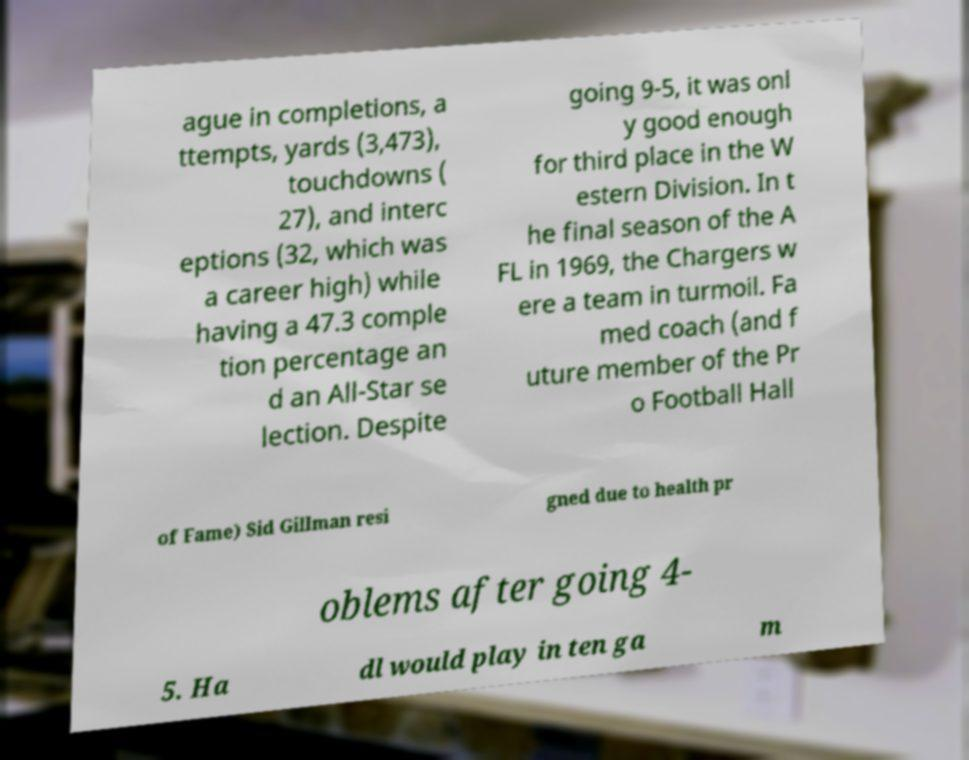I need the written content from this picture converted into text. Can you do that? ague in completions, a ttempts, yards (3,473), touchdowns ( 27), and interc eptions (32, which was a career high) while having a 47.3 comple tion percentage an d an All-Star se lection. Despite going 9-5, it was onl y good enough for third place in the W estern Division. In t he final season of the A FL in 1969, the Chargers w ere a team in turmoil. Fa med coach (and f uture member of the Pr o Football Hall of Fame) Sid Gillman resi gned due to health pr oblems after going 4- 5. Ha dl would play in ten ga m 